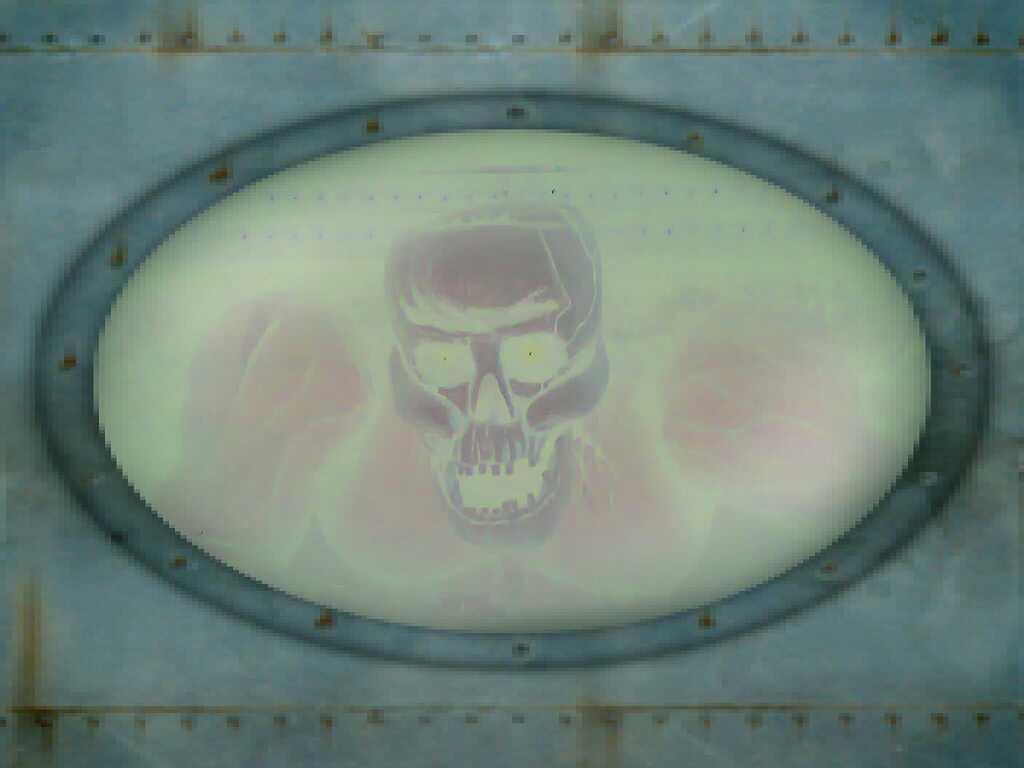In one or two sentences, can you explain what this image depicts? This might be an edited image, in this image in the center there is a skull. 